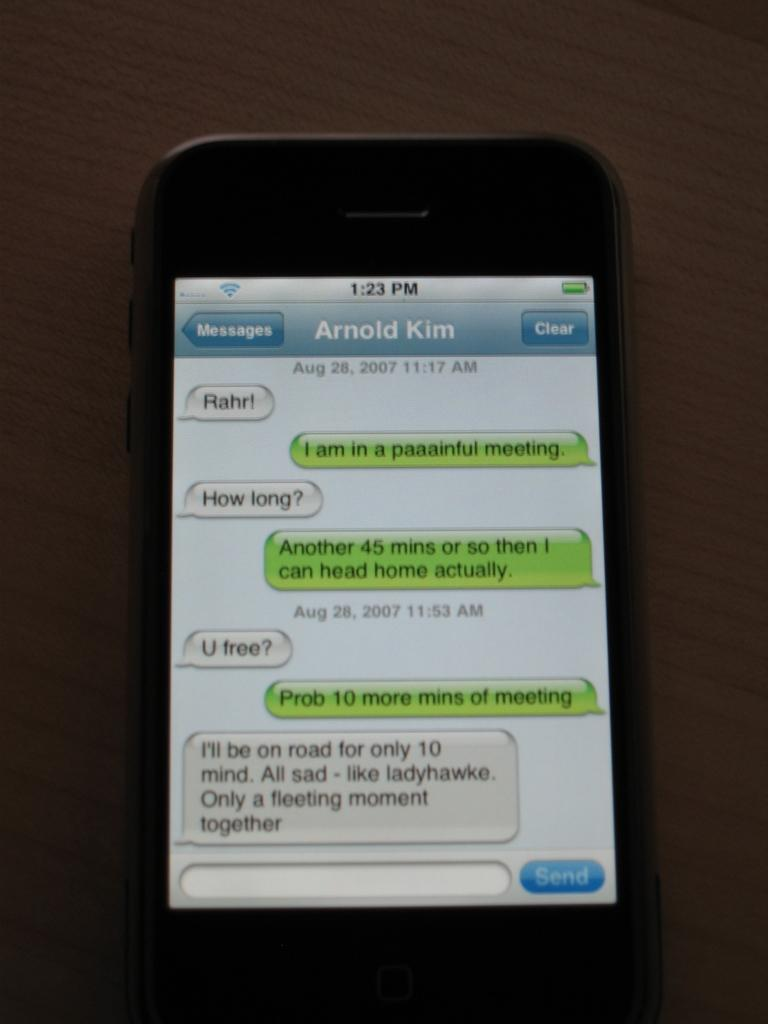Provide a one-sentence caption for the provided image. A phone showing messages to and from Arnold Kim. 